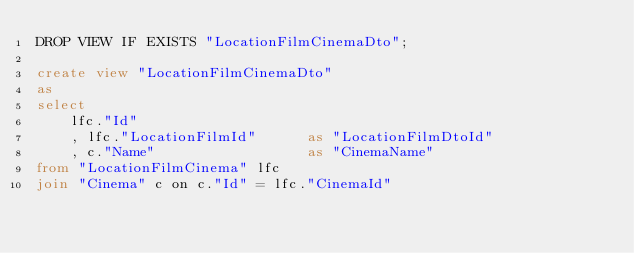<code> <loc_0><loc_0><loc_500><loc_500><_SQL_>DROP VIEW IF EXISTS "LocationFilmCinemaDto";

create view "LocationFilmCinemaDto"
as
select 
    lfc."Id"
    , lfc."LocationFilmId"      as "LocationFilmDtoId"
    , c."Name"                  as "CinemaName"
from "LocationFilmCinema" lfc
join "Cinema" c on c."Id" = lfc."CinemaId"</code> 